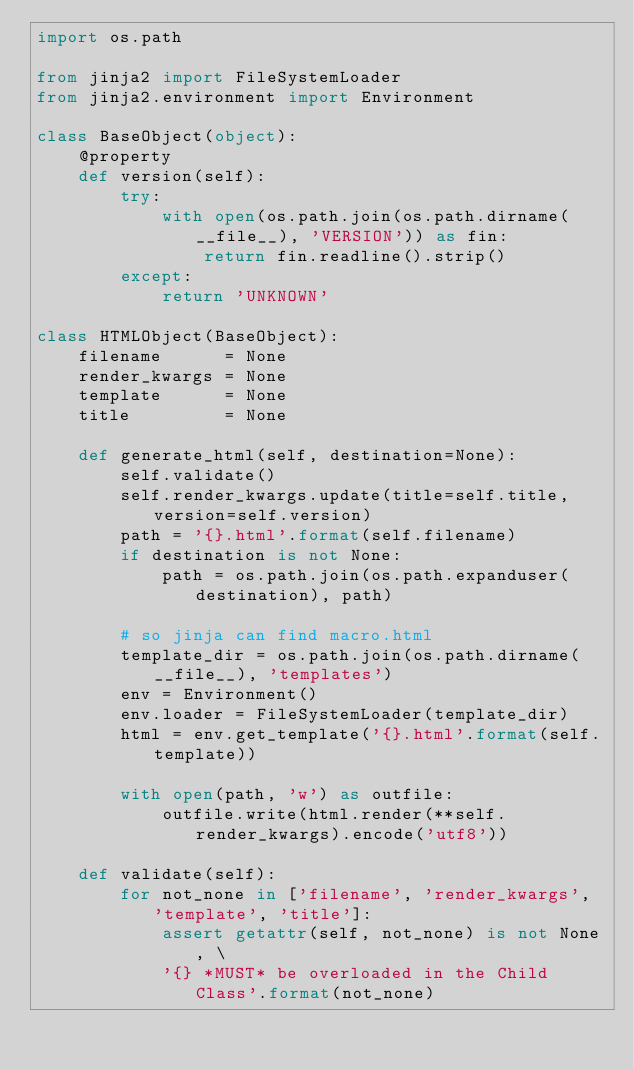Convert code to text. <code><loc_0><loc_0><loc_500><loc_500><_Python_>import os.path

from jinja2 import FileSystemLoader
from jinja2.environment import Environment

class BaseObject(object):
    @property
    def version(self):
        try:
            with open(os.path.join(os.path.dirname(__file__), 'VERSION')) as fin:
                return fin.readline().strip()
        except:
            return 'UNKNOWN'

class HTMLObject(BaseObject):
    filename      = None
    render_kwargs = None
    template      = None
    title         = None

    def generate_html(self, destination=None):
        self.validate()
        self.render_kwargs.update(title=self.title, version=self.version)
        path = '{}.html'.format(self.filename)
        if destination is not None:
            path = os.path.join(os.path.expanduser(destination), path)

        # so jinja can find macro.html
        template_dir = os.path.join(os.path.dirname(__file__), 'templates')
        env = Environment()
        env.loader = FileSystemLoader(template_dir)
        html = env.get_template('{}.html'.format(self.template))

        with open(path, 'w') as outfile:
            outfile.write(html.render(**self.render_kwargs).encode('utf8'))

    def validate(self):
        for not_none in ['filename', 'render_kwargs', 'template', 'title']:
            assert getattr(self, not_none) is not None, \
            '{} *MUST* be overloaded in the Child Class'.format(not_none)
</code> 